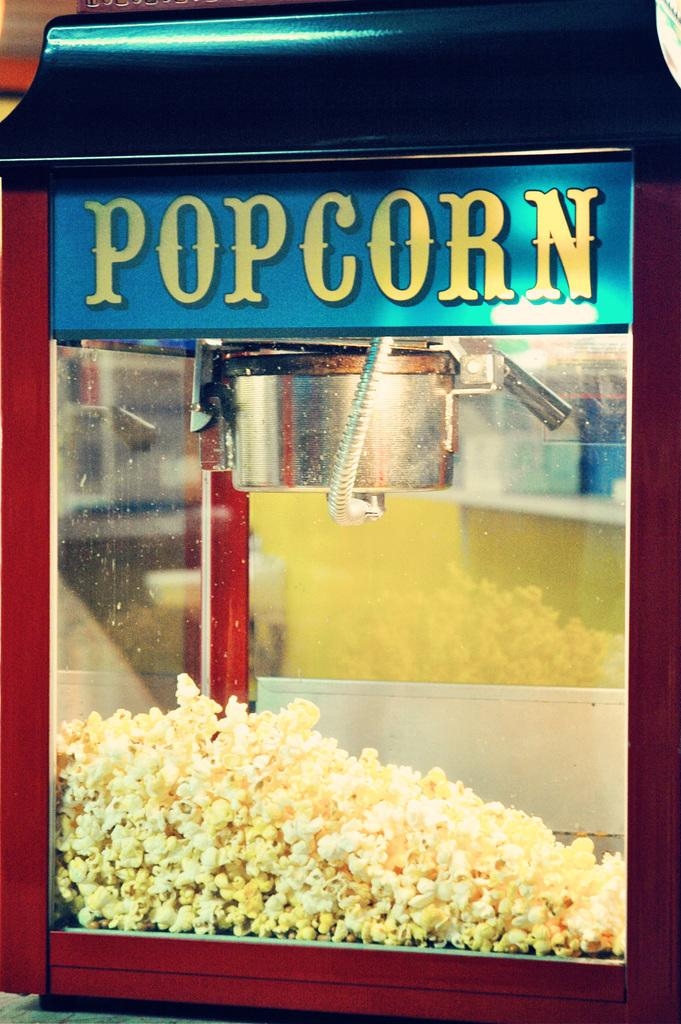Provide a one-sentence caption for the provided image. a red trimmed glass box labeled 'popcorn' in yellow. 